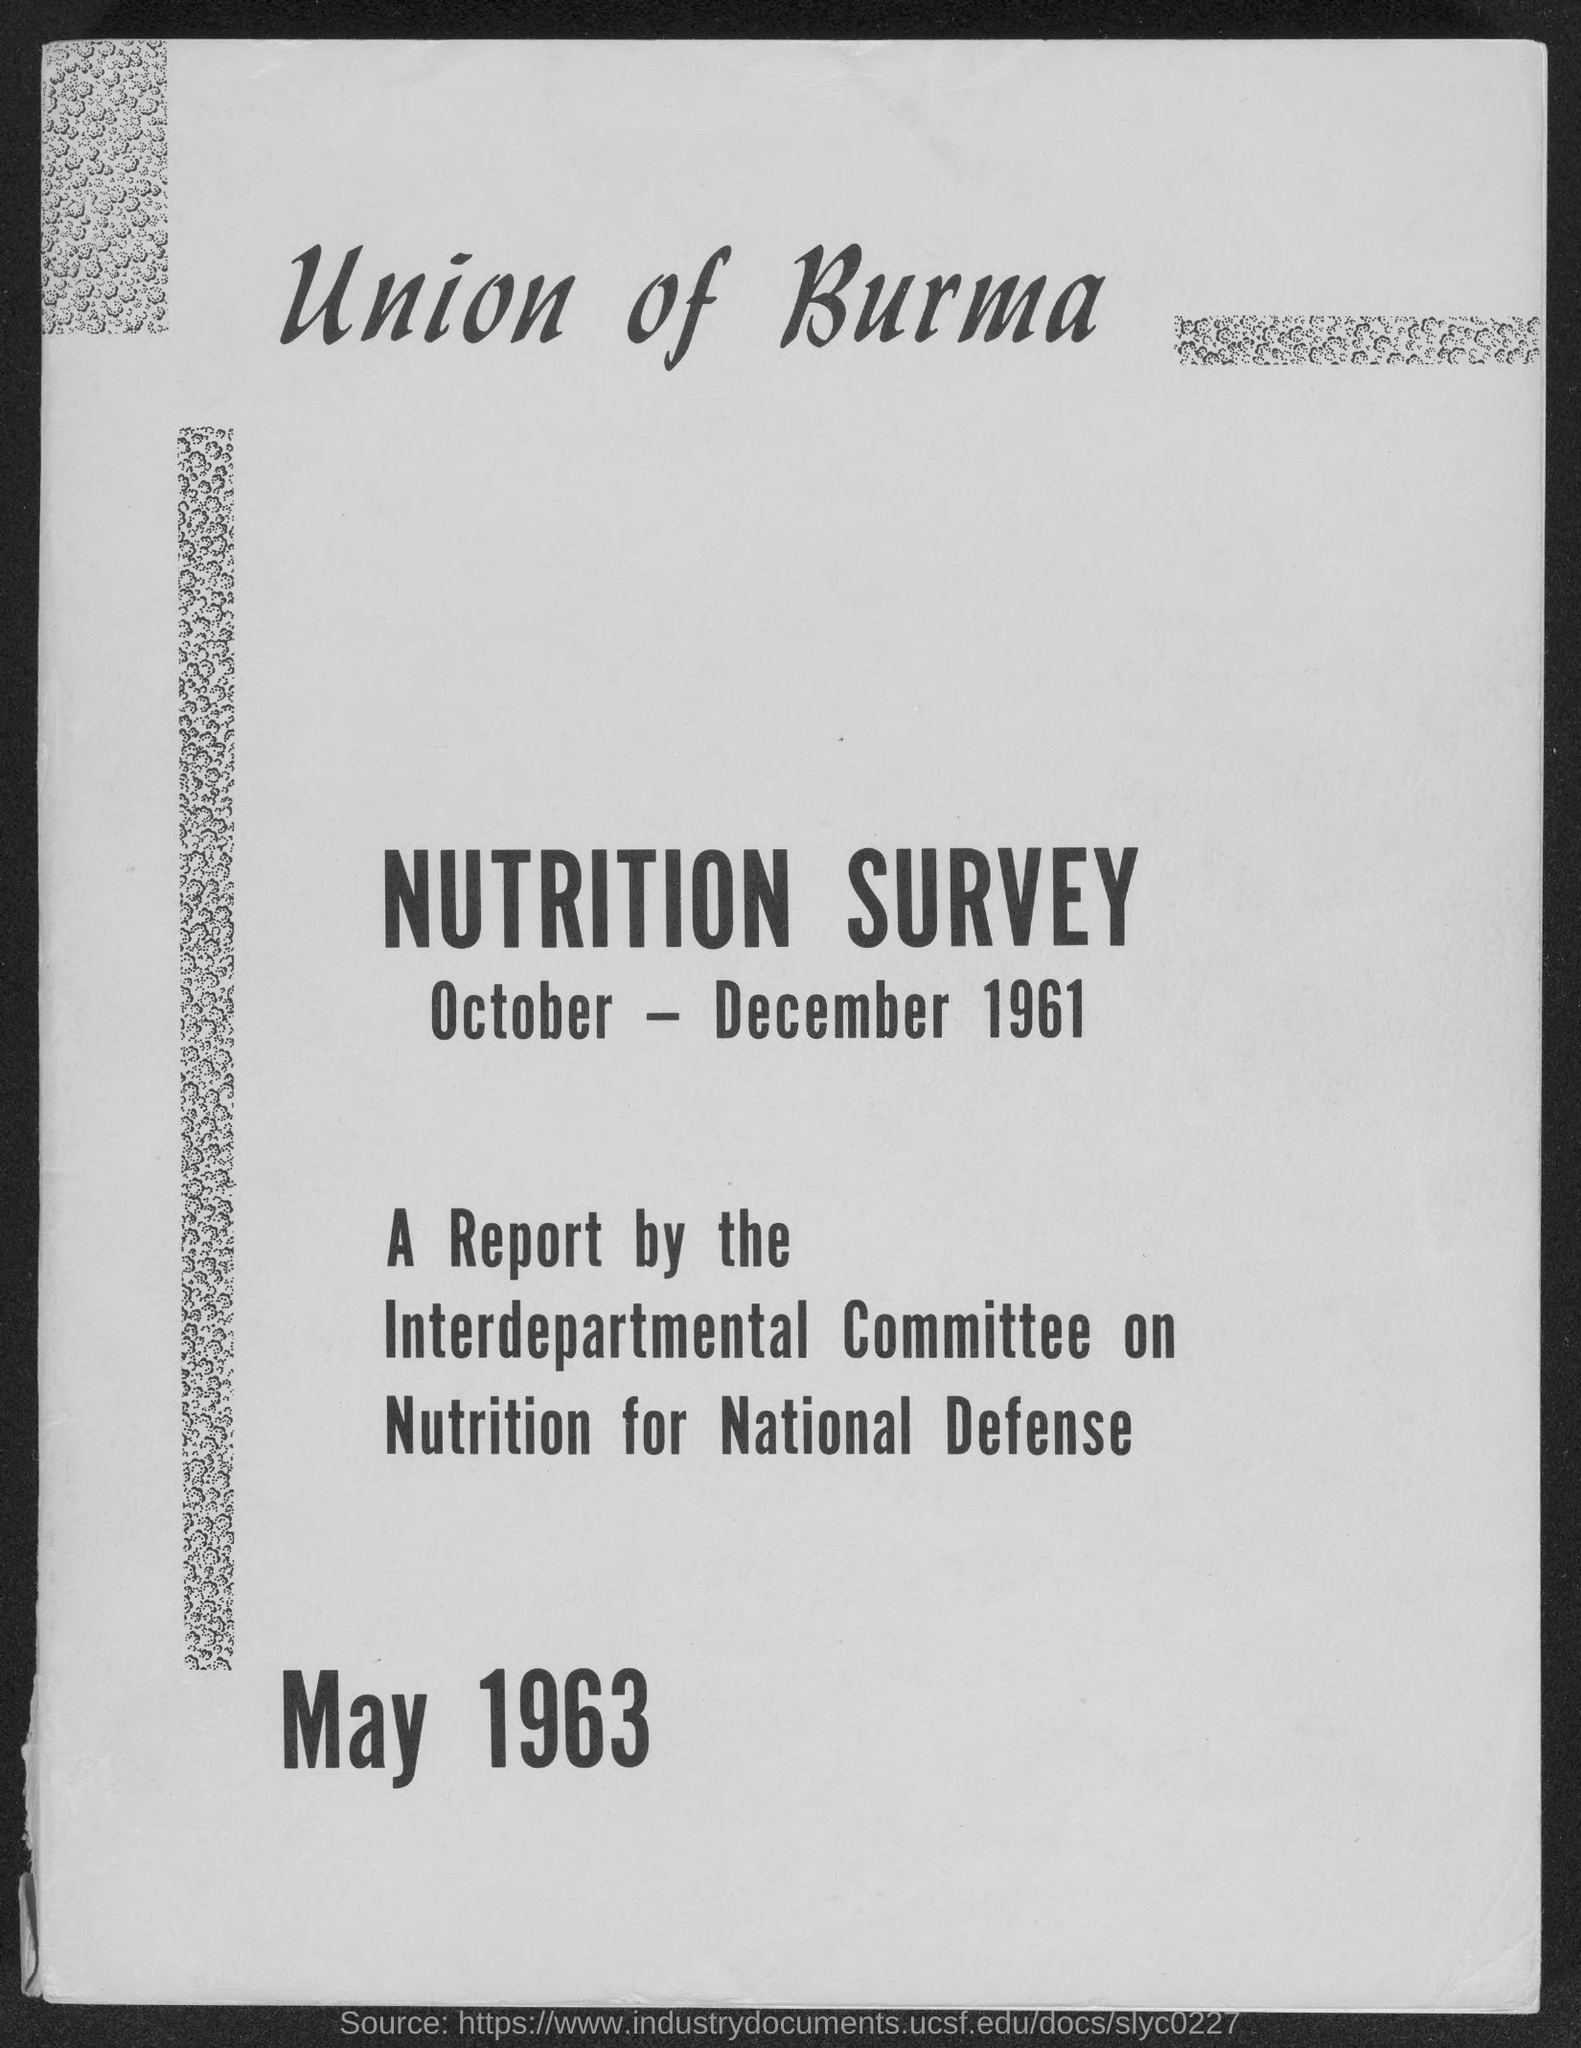What is the month and year at bottom of the  page ?
Keep it short and to the point. May 1963. 